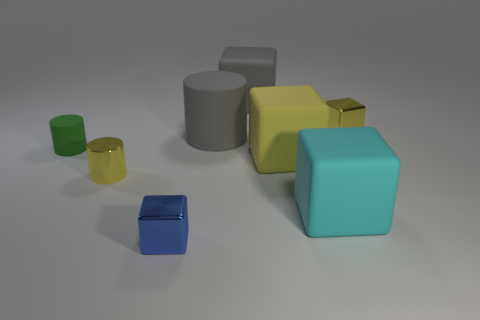What number of other objects are there of the same color as the small shiny cylinder?
Give a very brief answer. 2. There is a tiny yellow thing behind the big yellow thing; what shape is it?
Your answer should be very brief. Cube. Is the number of red things less than the number of green objects?
Provide a succinct answer. Yes. Do the tiny thing in front of the big cyan block and the large yellow block have the same material?
Provide a succinct answer. No. Is there any other thing that has the same size as the yellow cylinder?
Your answer should be compact. Yes. There is a tiny green matte cylinder; are there any small things in front of it?
Keep it short and to the point. Yes. There is a large thing that is behind the gray rubber object in front of the tiny block that is behind the small yellow cylinder; what color is it?
Provide a succinct answer. Gray. What is the shape of the yellow thing that is the same size as the cyan object?
Your answer should be compact. Cube. Are there more big cyan rubber cubes than small yellow things?
Keep it short and to the point. No. Is there a matte object in front of the small cube that is behind the yellow shiny cylinder?
Your response must be concise. Yes. 